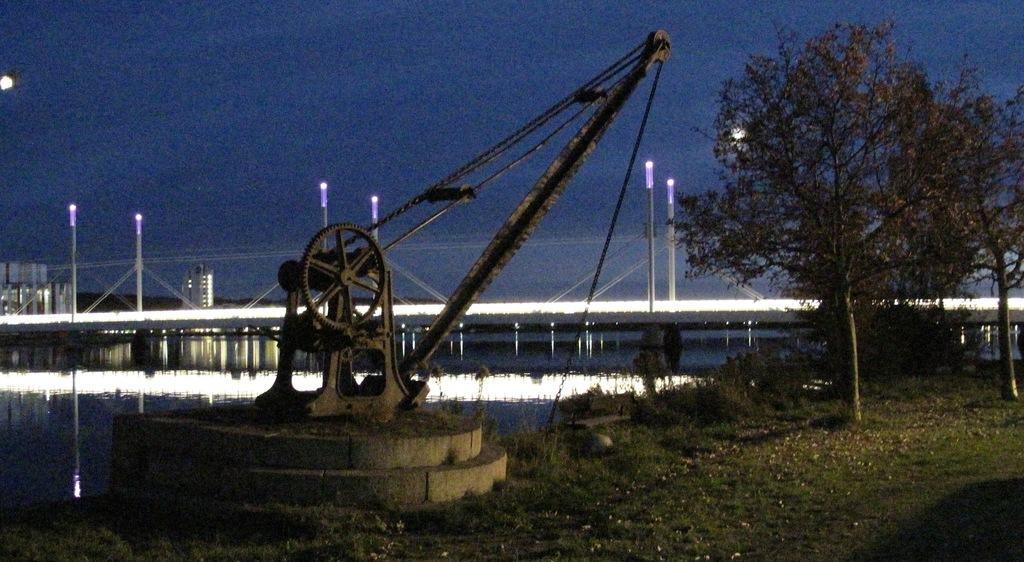Can you describe this image briefly? In the image there is a pulley, beside that there is grass and a tree, behind the pulley there is a water surface and in the background there are pole lights. 